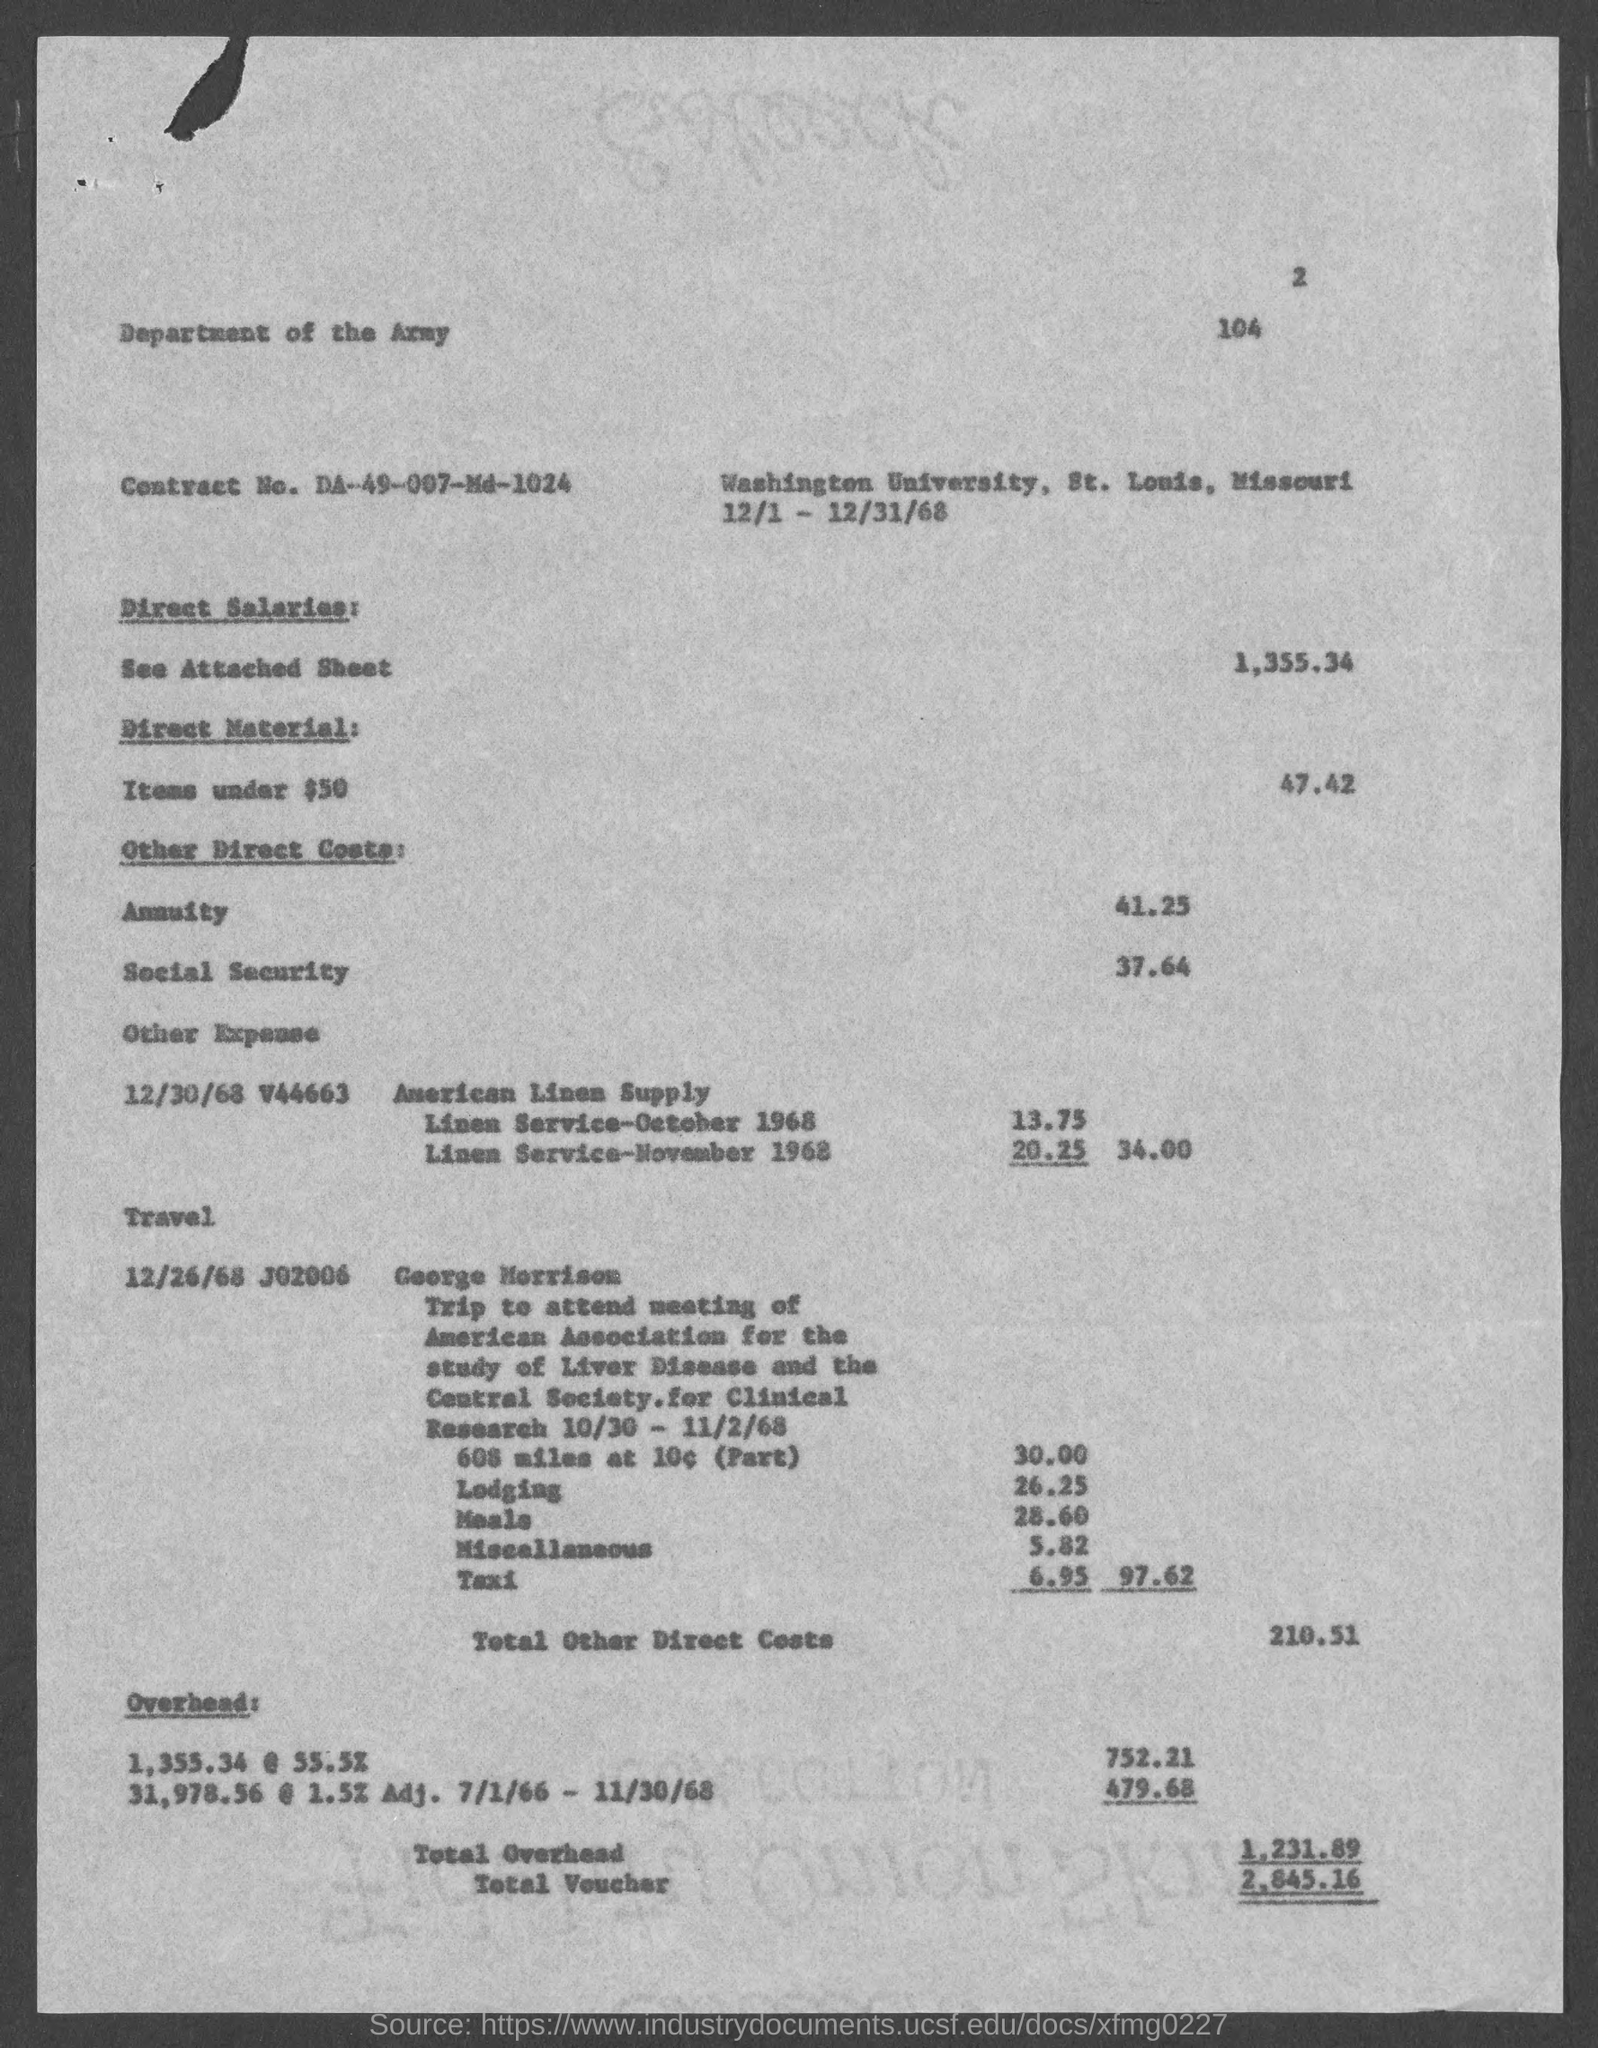Highlight a few significant elements in this photo. Washington University is located in St. Louis County. The page number at the top of the page is 2. The total other direct costs are $210.51. The contract number is DA-49-007-Md-1024. The total amount of vouchers is $2,845.16. 